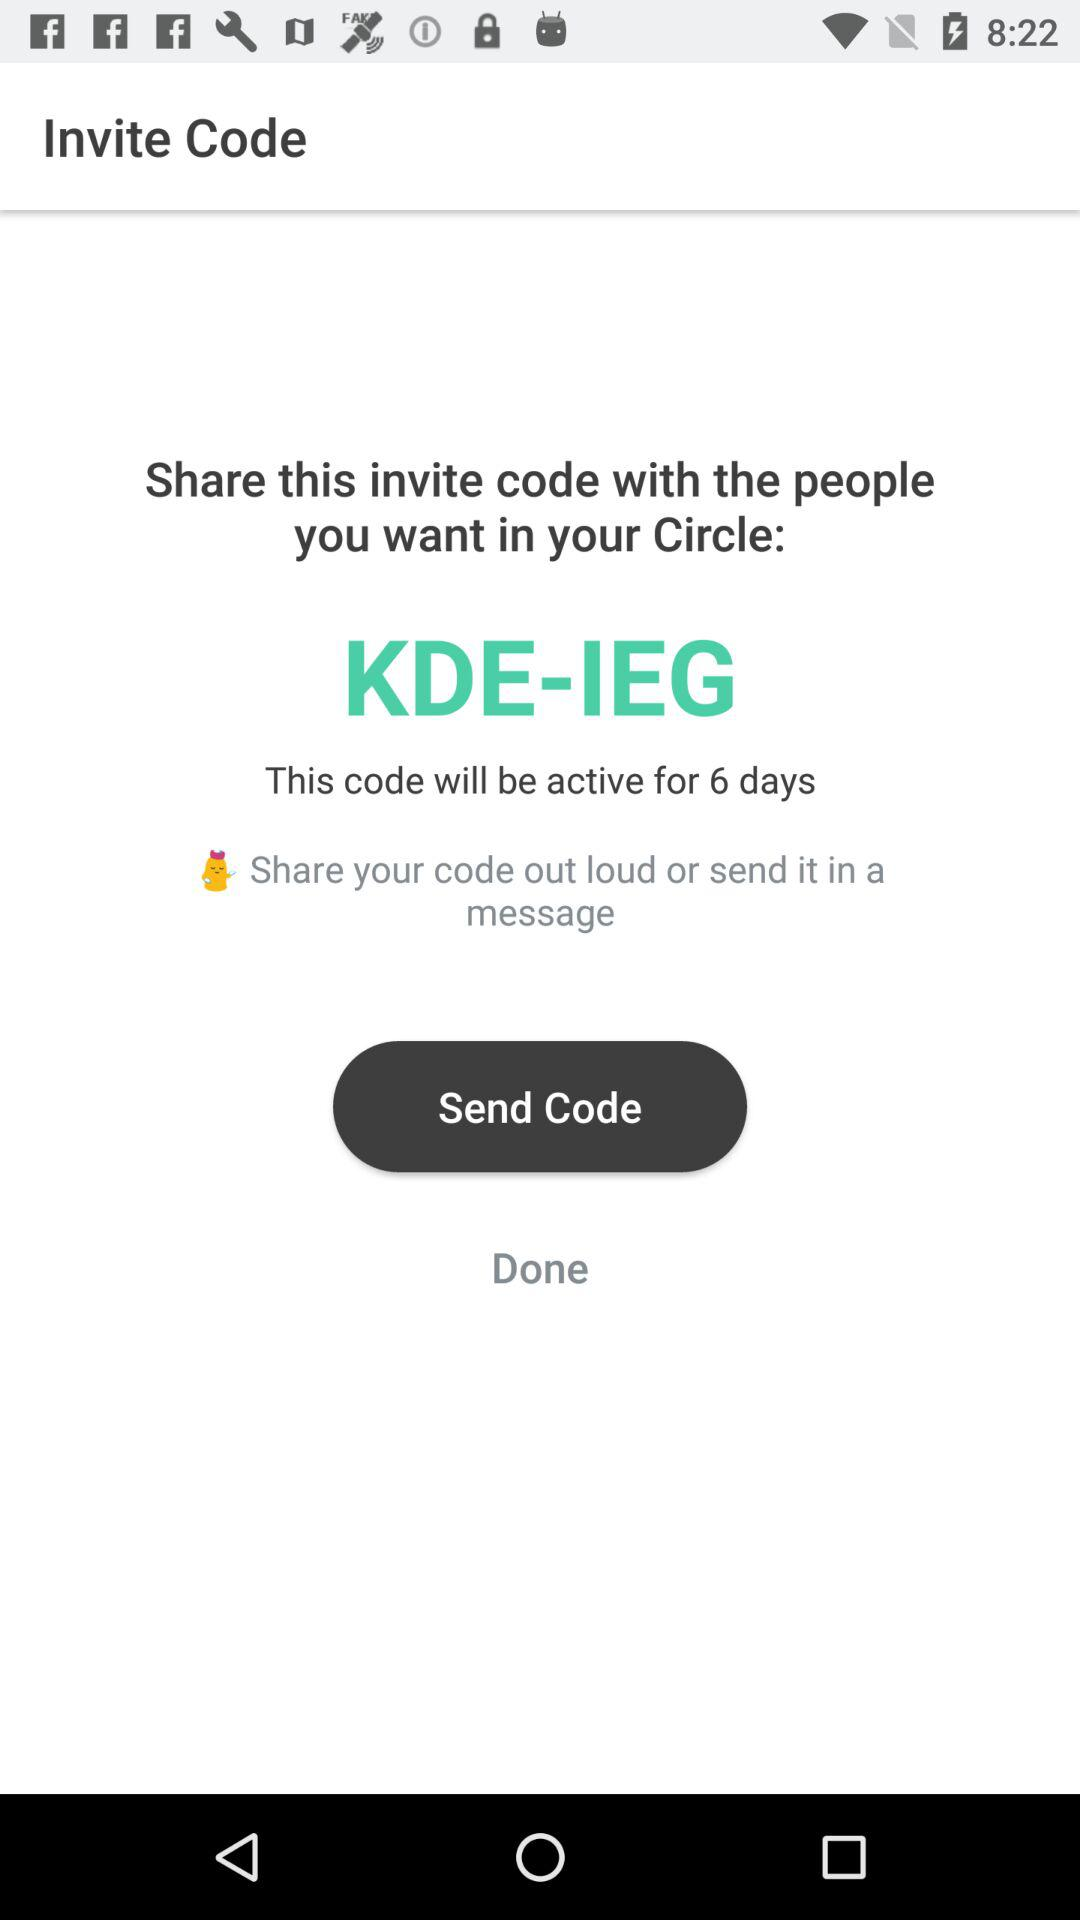For how long is the code valid? The code is valid for 6 days. 